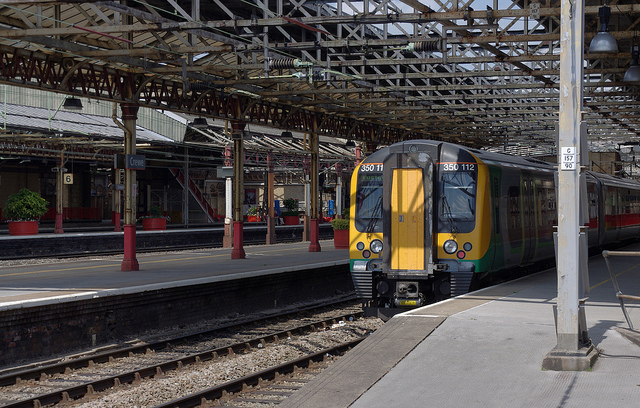<image>What pattern is on the pole? I am not sure about the pattern on the pole. It could be solid, have stripes, or no pattern at all. What pattern is on the pole? There is no pattern on the pole. 